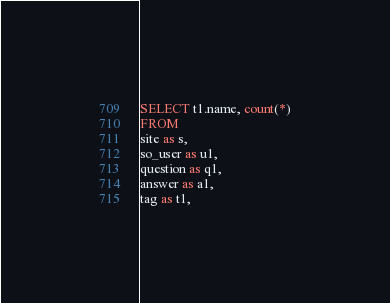<code> <loc_0><loc_0><loc_500><loc_500><_SQL_>SELECT t1.name, count(*)
FROM
site as s,
so_user as u1,
question as q1,
answer as a1,
tag as t1,</code> 